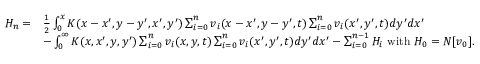<formula> <loc_0><loc_0><loc_500><loc_500>\begin{array} { r l } { H _ { n } = } & { \frac { 1 } { 2 } \int _ { 0 } ^ { x } K ( x - x ^ { \prime } , y - y ^ { \prime } , x ^ { \prime } , y ^ { \prime } ) \sum _ { i = 0 } ^ { n } v _ { i } ( x - x ^ { \prime } , y - y ^ { \prime } , t ) \sum _ { i = 0 } ^ { n } v _ { i } ( x ^ { \prime } , y ^ { \prime } , t ) d y ^ { \prime } d x ^ { \prime } } \\ & { - \int _ { 0 } ^ { \infty } K ( x , x ^ { \prime } , y , y ^ { \prime } ) \sum _ { i = 0 } ^ { n } v _ { i } ( x , y , t ) \sum _ { i = 0 } ^ { n } v _ { i } ( x ^ { \prime } , y ^ { \prime } , t ) d y ^ { \prime } d x ^ { \prime } - \sum _ { i = 0 } ^ { n - 1 } H _ { i } w i t h H _ { 0 } = N [ v _ { 0 } ] . } \end{array}</formula> 